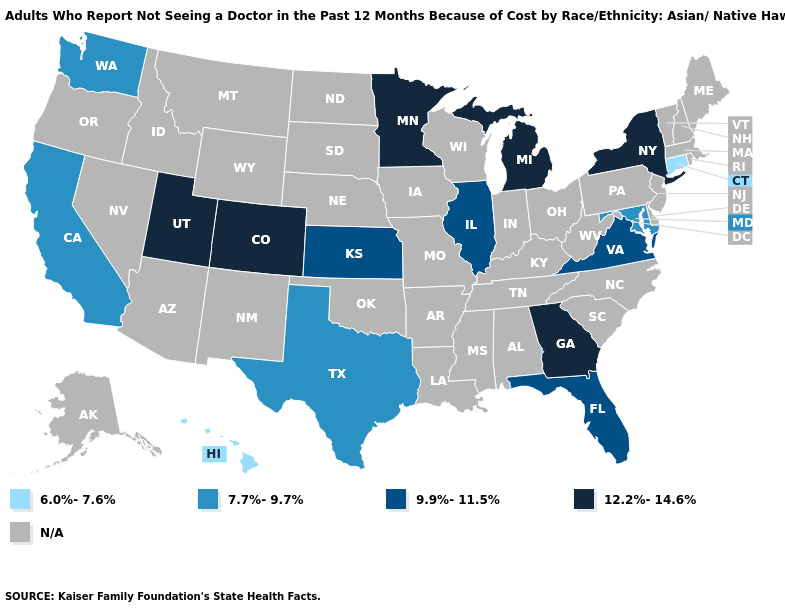Name the states that have a value in the range N/A?
Short answer required. Alabama, Alaska, Arizona, Arkansas, Delaware, Idaho, Indiana, Iowa, Kentucky, Louisiana, Maine, Massachusetts, Mississippi, Missouri, Montana, Nebraska, Nevada, New Hampshire, New Jersey, New Mexico, North Carolina, North Dakota, Ohio, Oklahoma, Oregon, Pennsylvania, Rhode Island, South Carolina, South Dakota, Tennessee, Vermont, West Virginia, Wisconsin, Wyoming. Among the states that border Wyoming , which have the highest value?
Write a very short answer. Colorado, Utah. What is the highest value in the USA?
Be succinct. 12.2%-14.6%. Among the states that border Louisiana , which have the lowest value?
Keep it brief. Texas. What is the lowest value in the South?
Keep it brief. 7.7%-9.7%. Does the first symbol in the legend represent the smallest category?
Concise answer only. Yes. What is the value of Texas?
Keep it brief. 7.7%-9.7%. What is the lowest value in the South?
Short answer required. 7.7%-9.7%. Name the states that have a value in the range 9.9%-11.5%?
Write a very short answer. Florida, Illinois, Kansas, Virginia. What is the value of Arizona?
Short answer required. N/A. What is the value of Mississippi?
Quick response, please. N/A. What is the lowest value in the South?
Keep it brief. 7.7%-9.7%. Which states have the lowest value in the MidWest?
Give a very brief answer. Illinois, Kansas. Does Illinois have the highest value in the MidWest?
Be succinct. No. 